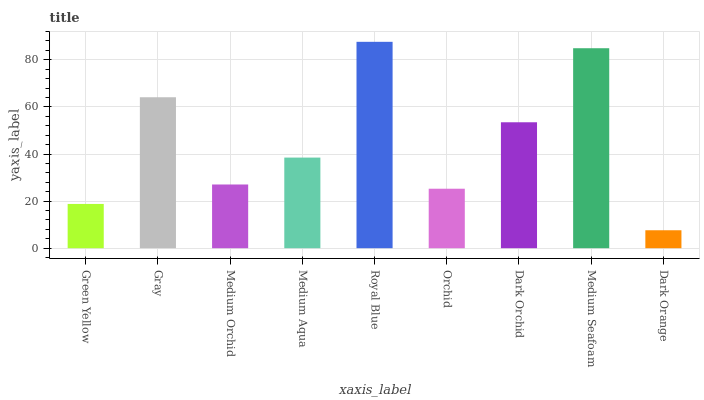Is Dark Orange the minimum?
Answer yes or no. Yes. Is Royal Blue the maximum?
Answer yes or no. Yes. Is Gray the minimum?
Answer yes or no. No. Is Gray the maximum?
Answer yes or no. No. Is Gray greater than Green Yellow?
Answer yes or no. Yes. Is Green Yellow less than Gray?
Answer yes or no. Yes. Is Green Yellow greater than Gray?
Answer yes or no. No. Is Gray less than Green Yellow?
Answer yes or no. No. Is Medium Aqua the high median?
Answer yes or no. Yes. Is Medium Aqua the low median?
Answer yes or no. Yes. Is Dark Orchid the high median?
Answer yes or no. No. Is Green Yellow the low median?
Answer yes or no. No. 